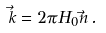<formula> <loc_0><loc_0><loc_500><loc_500>\vec { k } = 2 \pi H _ { 0 } \vec { n } \, .</formula> 